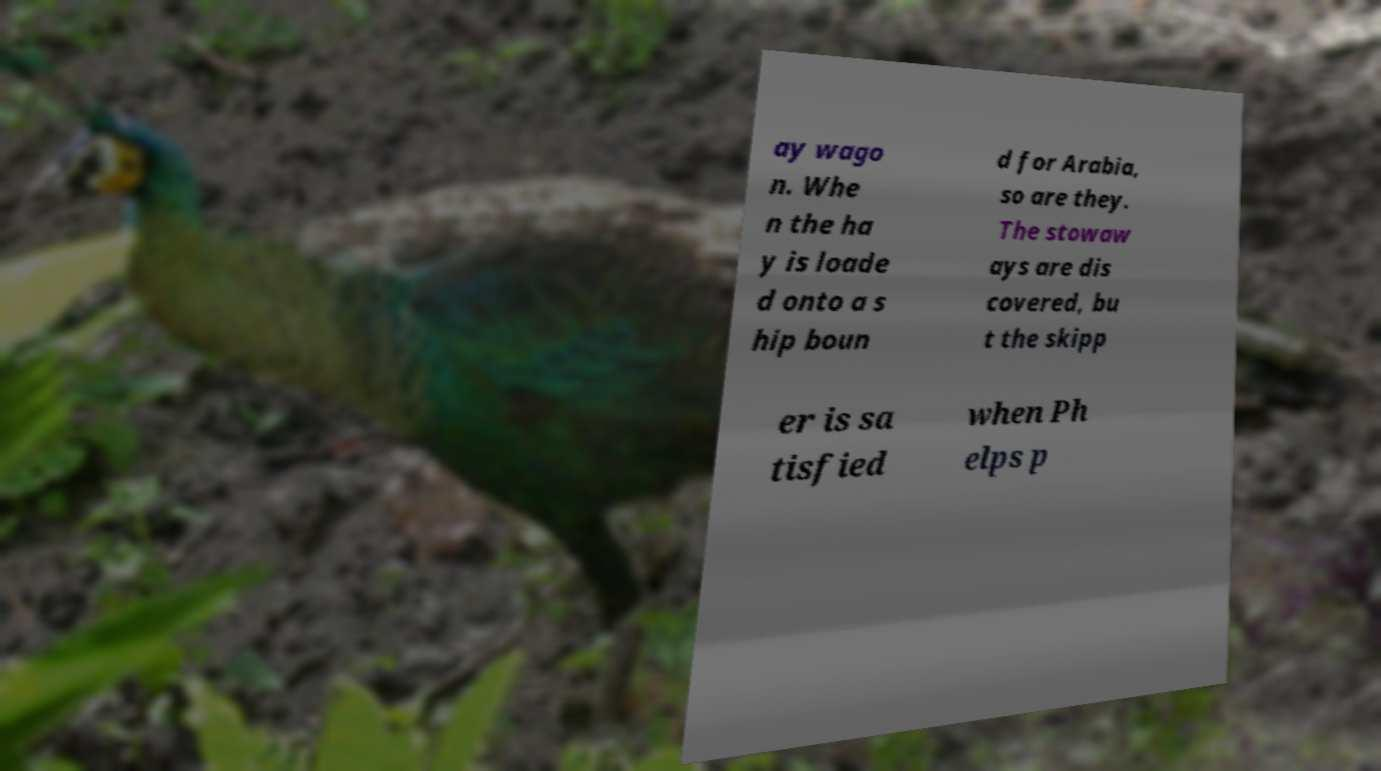There's text embedded in this image that I need extracted. Can you transcribe it verbatim? ay wago n. Whe n the ha y is loade d onto a s hip boun d for Arabia, so are they. The stowaw ays are dis covered, bu t the skipp er is sa tisfied when Ph elps p 